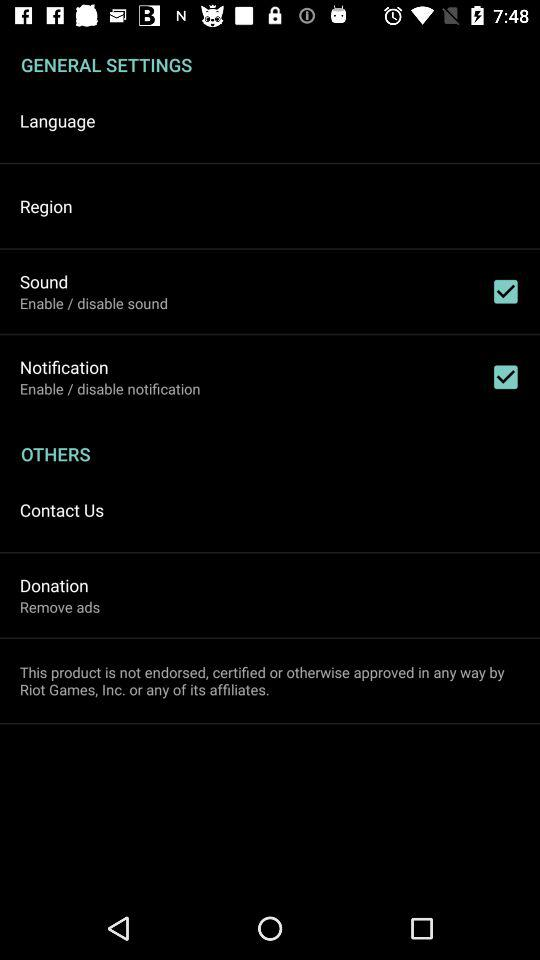What is the status of "Sound"? The status is "on". 